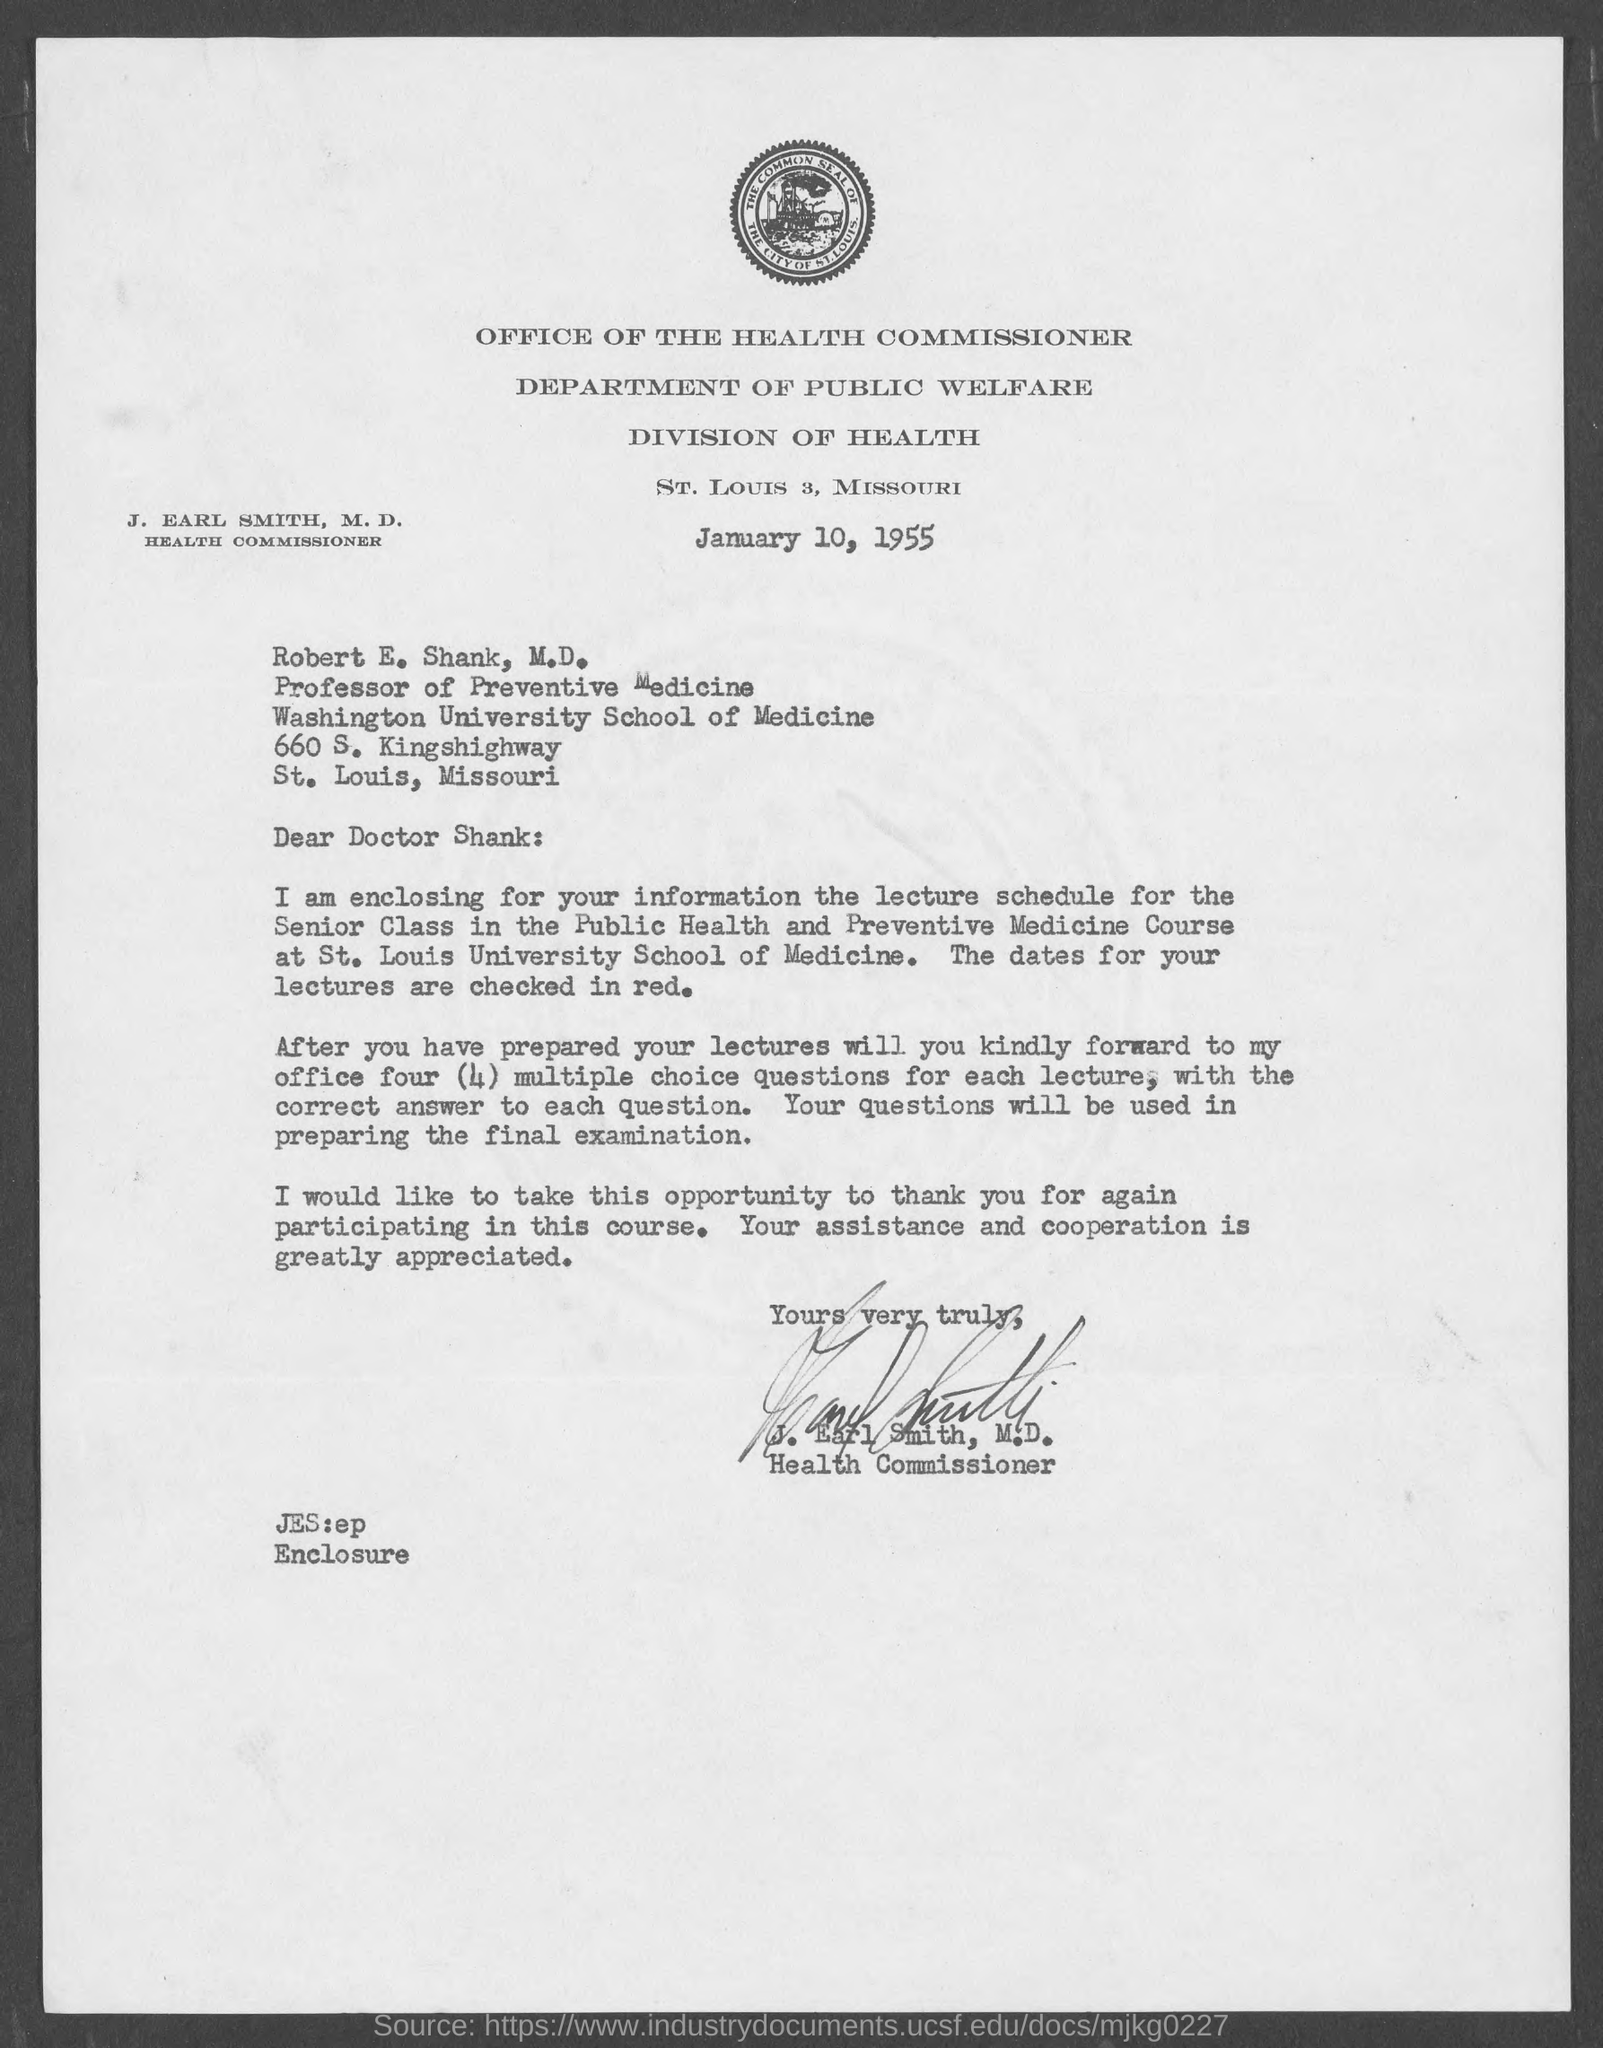To which university does Dr.Robert E. Shank, M.D. belong to?
Ensure brevity in your answer.  Washington University school of medicine. The letter is dated on?
Offer a very short reply. January 10, 1955. Who is the health commissioner of department of public welfare?
Offer a very short reply. J . Earl Smith, M.D. Who wrote this letter?
Provide a succinct answer. J. Earl Smith. To whom is this letter written to?
Offer a very short reply. Robert E. Shank. What is the address of division of health ?
Offer a terse response. St. Louis 3, Missouri. 